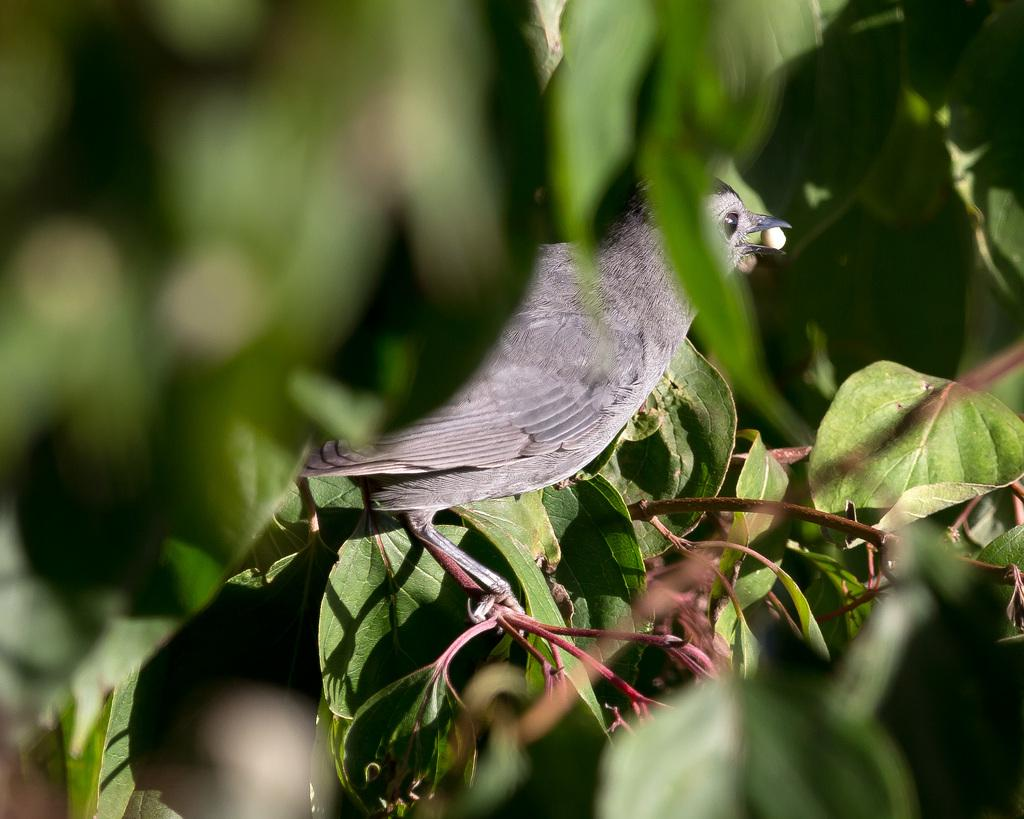What type of animal can be seen in the image? There is a bird in the image. What color is the bird? The bird is gray in color. Where is the bird located in the image? The bird is sitting on a stem. What else can be seen in the image besides the bird? There are leaves visible in the image. What type of slope can be seen in the image? There is no slope present in the image; it features a bird sitting on a stem with leaves visible. What does the image smell like? The image does not have a smell, as it is a visual representation and not a physical object. 